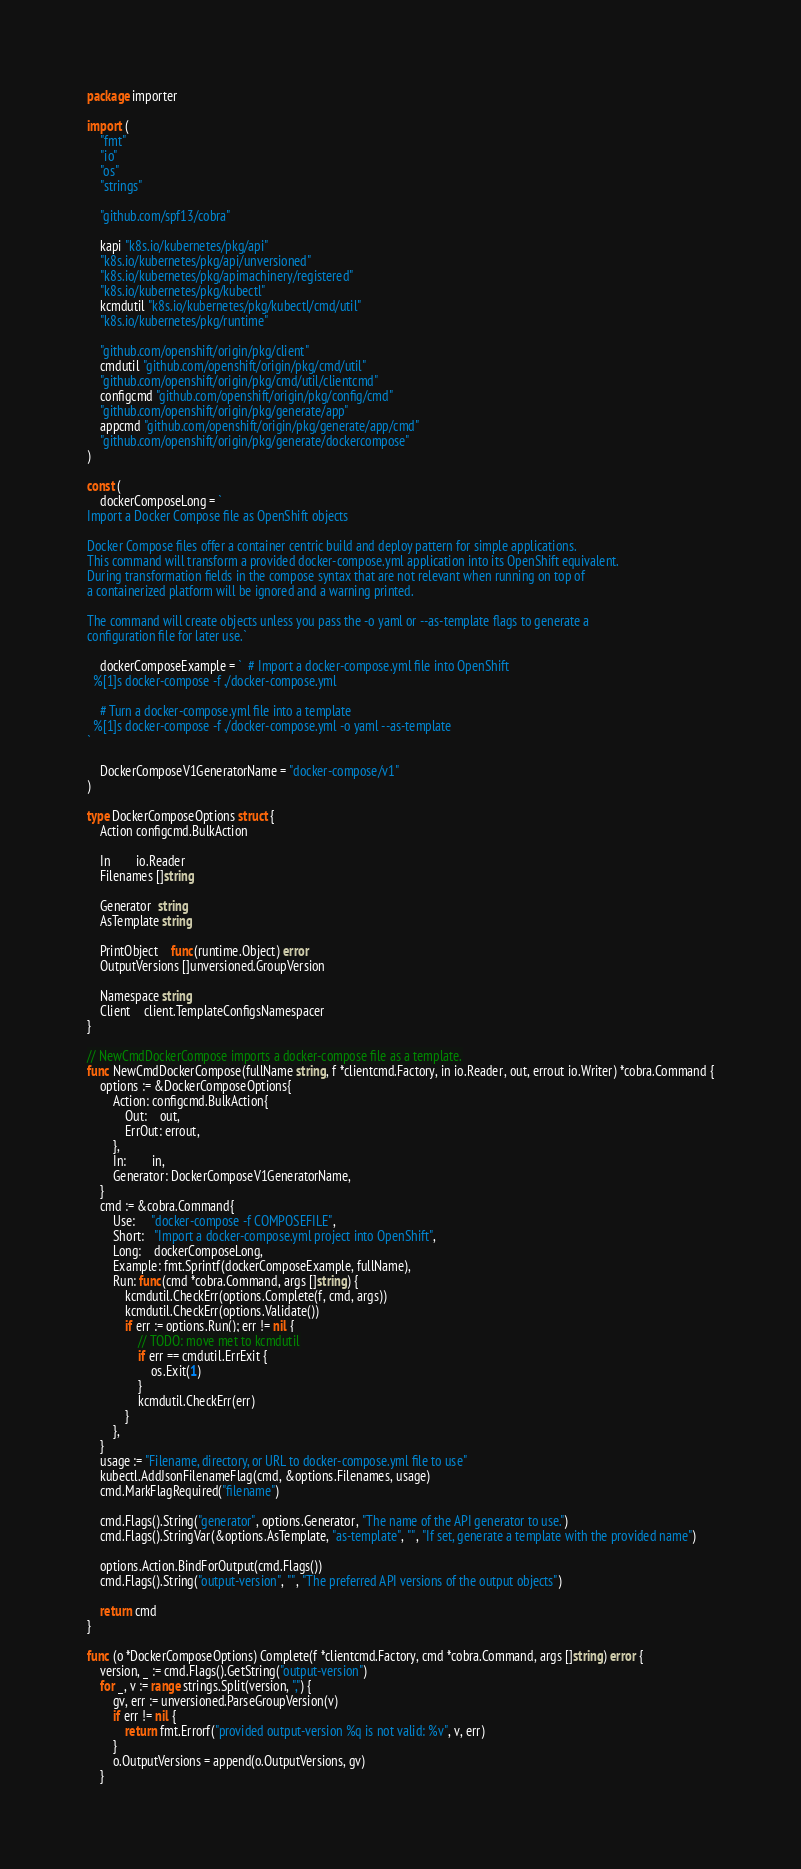<code> <loc_0><loc_0><loc_500><loc_500><_Go_>package importer

import (
	"fmt"
	"io"
	"os"
	"strings"

	"github.com/spf13/cobra"

	kapi "k8s.io/kubernetes/pkg/api"
	"k8s.io/kubernetes/pkg/api/unversioned"
	"k8s.io/kubernetes/pkg/apimachinery/registered"
	"k8s.io/kubernetes/pkg/kubectl"
	kcmdutil "k8s.io/kubernetes/pkg/kubectl/cmd/util"
	"k8s.io/kubernetes/pkg/runtime"

	"github.com/openshift/origin/pkg/client"
	cmdutil "github.com/openshift/origin/pkg/cmd/util"
	"github.com/openshift/origin/pkg/cmd/util/clientcmd"
	configcmd "github.com/openshift/origin/pkg/config/cmd"
	"github.com/openshift/origin/pkg/generate/app"
	appcmd "github.com/openshift/origin/pkg/generate/app/cmd"
	"github.com/openshift/origin/pkg/generate/dockercompose"
)

const (
	dockerComposeLong = `
Import a Docker Compose file as OpenShift objects

Docker Compose files offer a container centric build and deploy pattern for simple applications.
This command will transform a provided docker-compose.yml application into its OpenShift equivalent.
During transformation fields in the compose syntax that are not relevant when running on top of
a containerized platform will be ignored and a warning printed.

The command will create objects unless you pass the -o yaml or --as-template flags to generate a
configuration file for later use.`

	dockerComposeExample = `  # Import a docker-compose.yml file into OpenShift
  %[1]s docker-compose -f ./docker-compose.yml

	# Turn a docker-compose.yml file into a template
  %[1]s docker-compose -f ./docker-compose.yml -o yaml --as-template
`

	DockerComposeV1GeneratorName = "docker-compose/v1"
)

type DockerComposeOptions struct {
	Action configcmd.BulkAction

	In        io.Reader
	Filenames []string

	Generator  string
	AsTemplate string

	PrintObject    func(runtime.Object) error
	OutputVersions []unversioned.GroupVersion

	Namespace string
	Client    client.TemplateConfigsNamespacer
}

// NewCmdDockerCompose imports a docker-compose file as a template.
func NewCmdDockerCompose(fullName string, f *clientcmd.Factory, in io.Reader, out, errout io.Writer) *cobra.Command {
	options := &DockerComposeOptions{
		Action: configcmd.BulkAction{
			Out:    out,
			ErrOut: errout,
		},
		In:        in,
		Generator: DockerComposeV1GeneratorName,
	}
	cmd := &cobra.Command{
		Use:     "docker-compose -f COMPOSEFILE",
		Short:   "Import a docker-compose.yml project into OpenShift",
		Long:    dockerComposeLong,
		Example: fmt.Sprintf(dockerComposeExample, fullName),
		Run: func(cmd *cobra.Command, args []string) {
			kcmdutil.CheckErr(options.Complete(f, cmd, args))
			kcmdutil.CheckErr(options.Validate())
			if err := options.Run(); err != nil {
				// TODO: move met to kcmdutil
				if err == cmdutil.ErrExit {
					os.Exit(1)
				}
				kcmdutil.CheckErr(err)
			}
		},
	}
	usage := "Filename, directory, or URL to docker-compose.yml file to use"
	kubectl.AddJsonFilenameFlag(cmd, &options.Filenames, usage)
	cmd.MarkFlagRequired("filename")

	cmd.Flags().String("generator", options.Generator, "The name of the API generator to use.")
	cmd.Flags().StringVar(&options.AsTemplate, "as-template", "", "If set, generate a template with the provided name")

	options.Action.BindForOutput(cmd.Flags())
	cmd.Flags().String("output-version", "", "The preferred API versions of the output objects")

	return cmd
}

func (o *DockerComposeOptions) Complete(f *clientcmd.Factory, cmd *cobra.Command, args []string) error {
	version, _ := cmd.Flags().GetString("output-version")
	for _, v := range strings.Split(version, ",") {
		gv, err := unversioned.ParseGroupVersion(v)
		if err != nil {
			return fmt.Errorf("provided output-version %q is not valid: %v", v, err)
		}
		o.OutputVersions = append(o.OutputVersions, gv)
	}</code> 